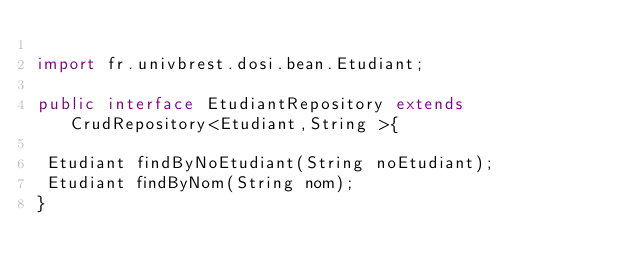<code> <loc_0><loc_0><loc_500><loc_500><_Java_>
import fr.univbrest.dosi.bean.Etudiant;

public interface EtudiantRepository extends CrudRepository<Etudiant,String >{
	
 Etudiant findByNoEtudiant(String noEtudiant);
 Etudiant findByNom(String nom);
}
</code> 